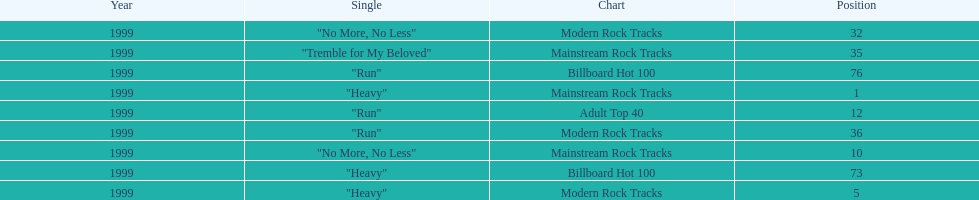How many singles from "dosage" appeared on the modern rock tracks charts? 3. 